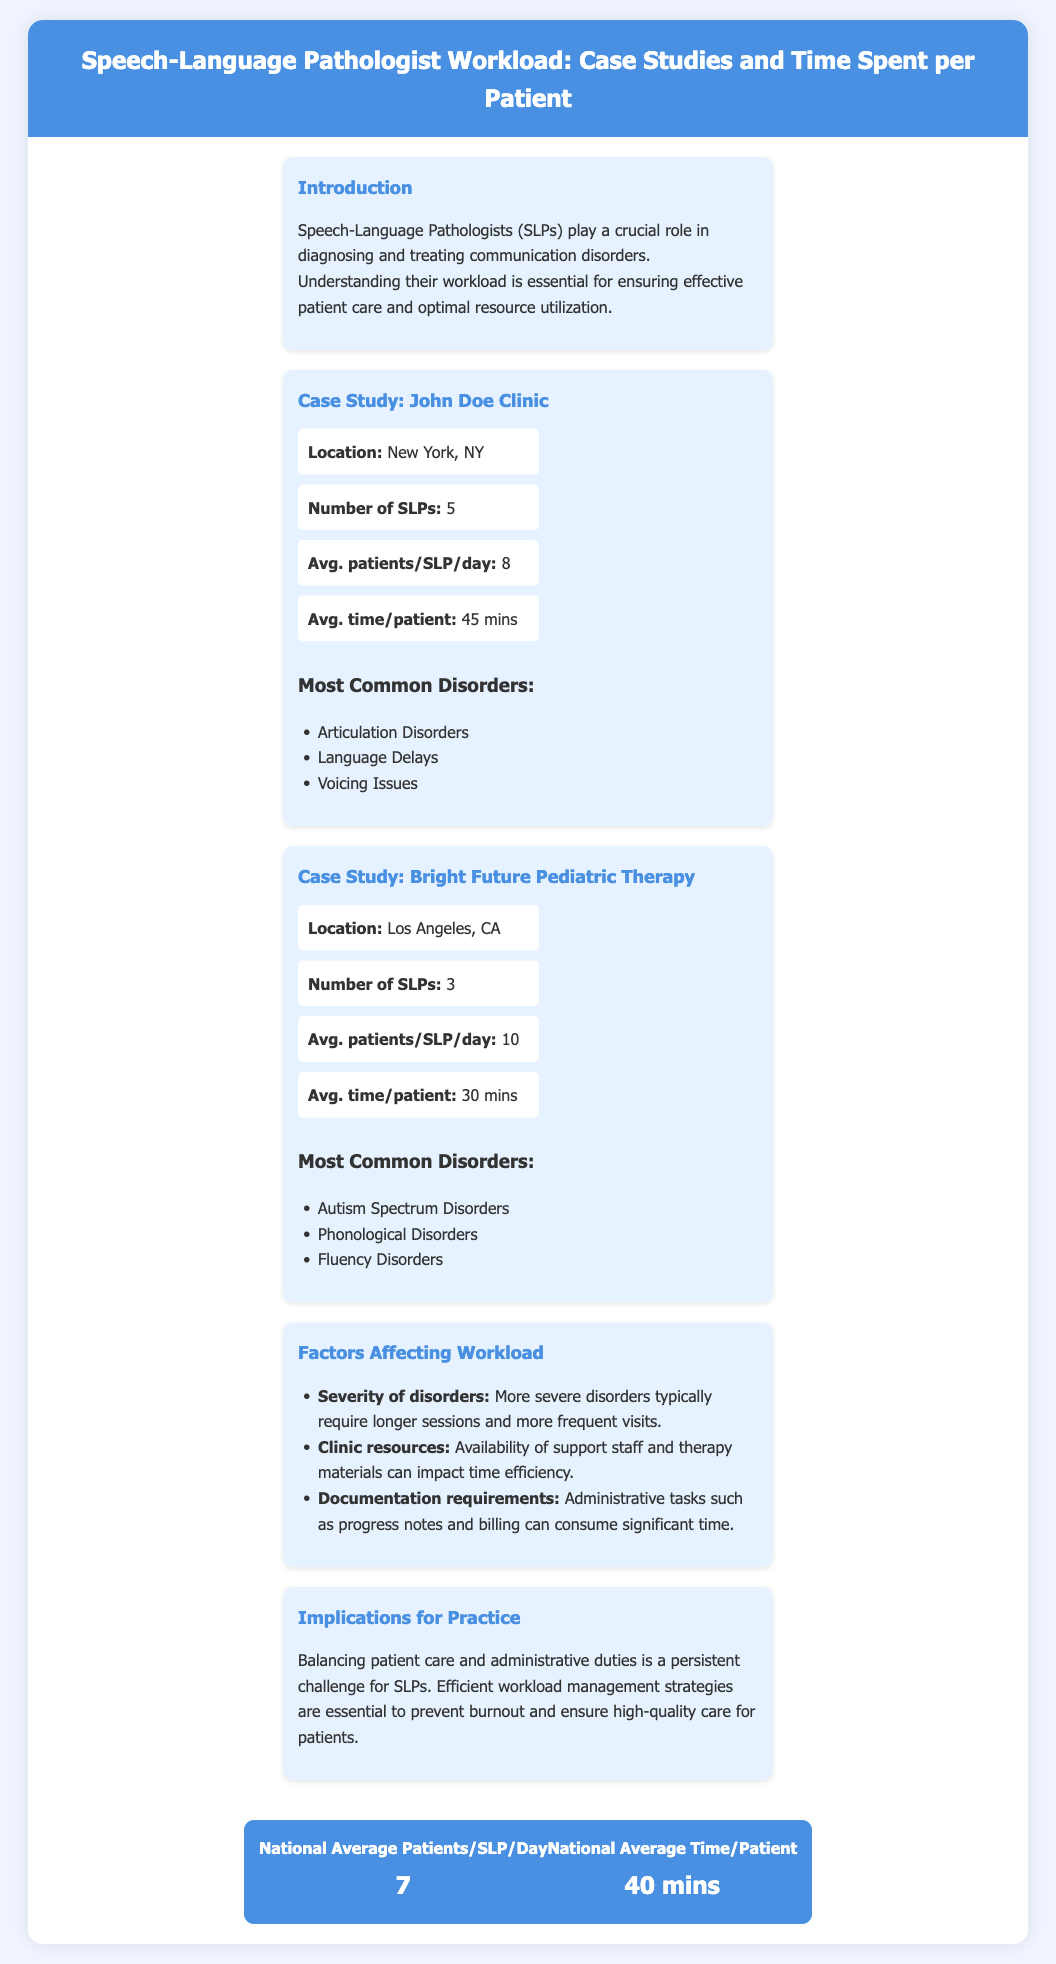What is the location of John Doe Clinic? The location of John Doe Clinic is provided in the case study section of the document.
Answer: New York, NY How many SLPs work at Bright Future Pediatric Therapy? The number of SLPs is specified in the clinic information of Bright Future Pediatric Therapy.
Answer: 3 What is the average time spent per patient at John Doe Clinic? The average time per patient is stated in the case study for John Doe Clinic.
Answer: 45 mins Which disorder is most common at Bright Future Pediatric Therapy? The document lists the most common disorders for Bright Future Pediatric Therapy.
Answer: Autism Spectrum Disorders What is the national average number of patients per SLP per day? This average is provided in the national averages section of the document.
Answer: 7 How does severity of disorders affect SLP workload? The document explains that severity affects session length and frequency of visits, indicating a reasoning behind the workload.
Answer: Longer sessions What is the average time spent per patient according to national averages? The national average for time spent per patient is given in the national averages section of the document.
Answer: 40 mins What challenge do SLPs face according to the implications for practice? The document discusses the challenges faced by SLPs, particularly in managing patient care and administrative duties.
Answer: Burnout What are clinic resources' effects on SLP workload? The document states how clinic resources affect time efficiency in therapy practices.
Answer: Impact time efficiency 